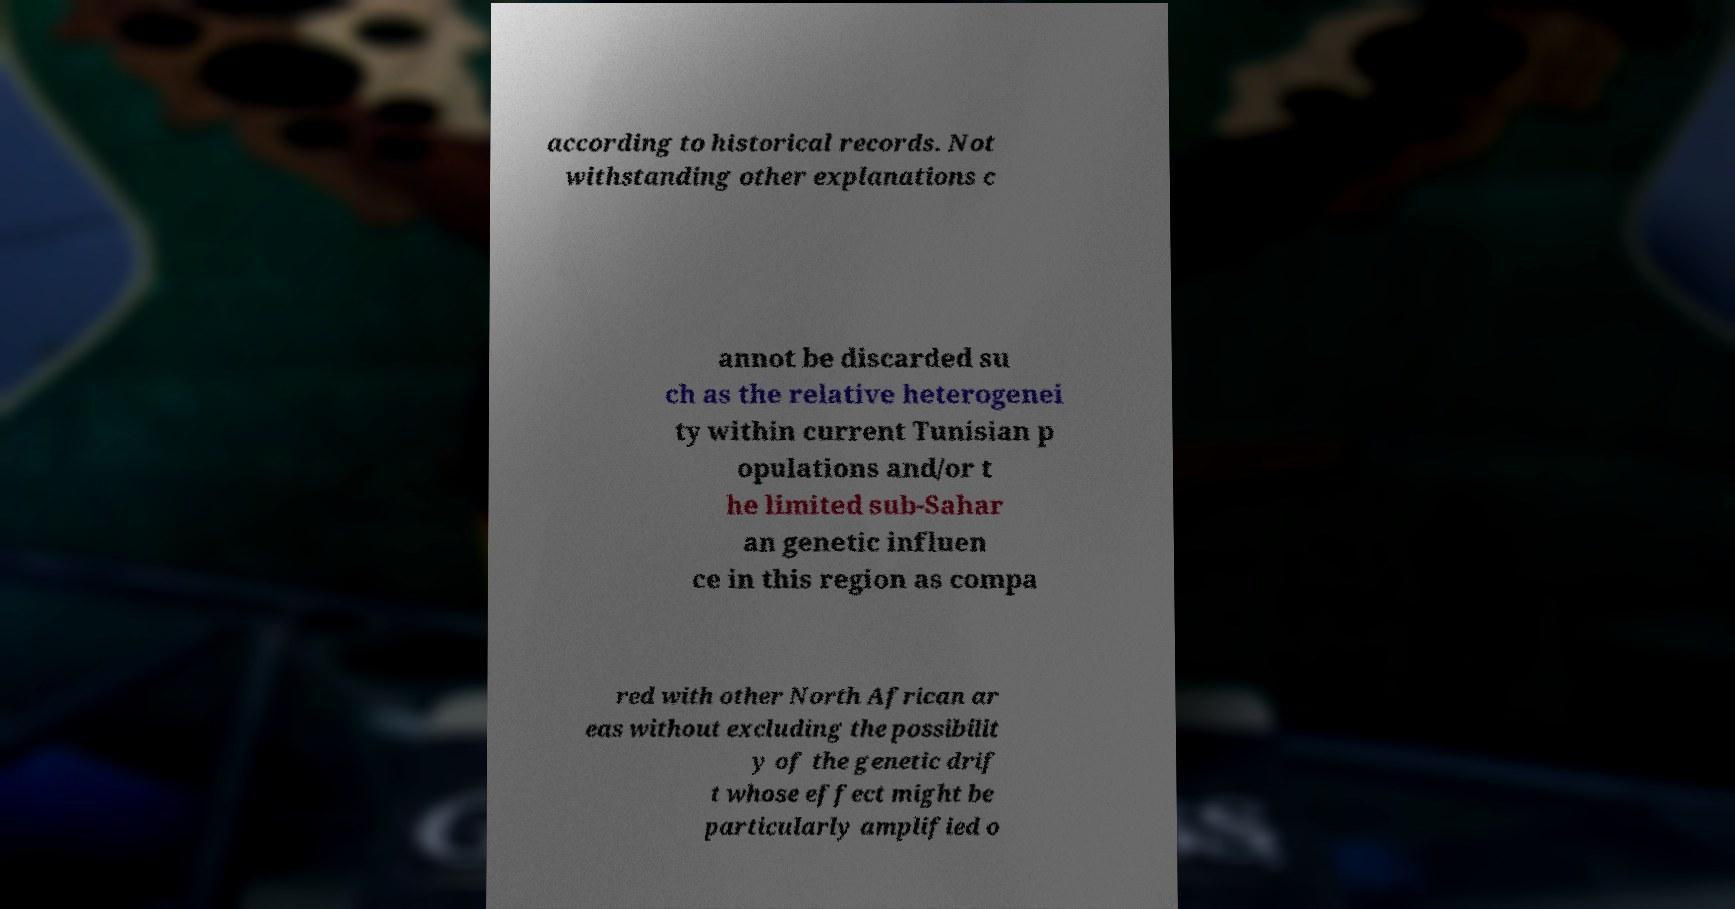I need the written content from this picture converted into text. Can you do that? according to historical records. Not withstanding other explanations c annot be discarded su ch as the relative heterogenei ty within current Tunisian p opulations and/or t he limited sub-Sahar an genetic influen ce in this region as compa red with other North African ar eas without excluding the possibilit y of the genetic drif t whose effect might be particularly amplified o 